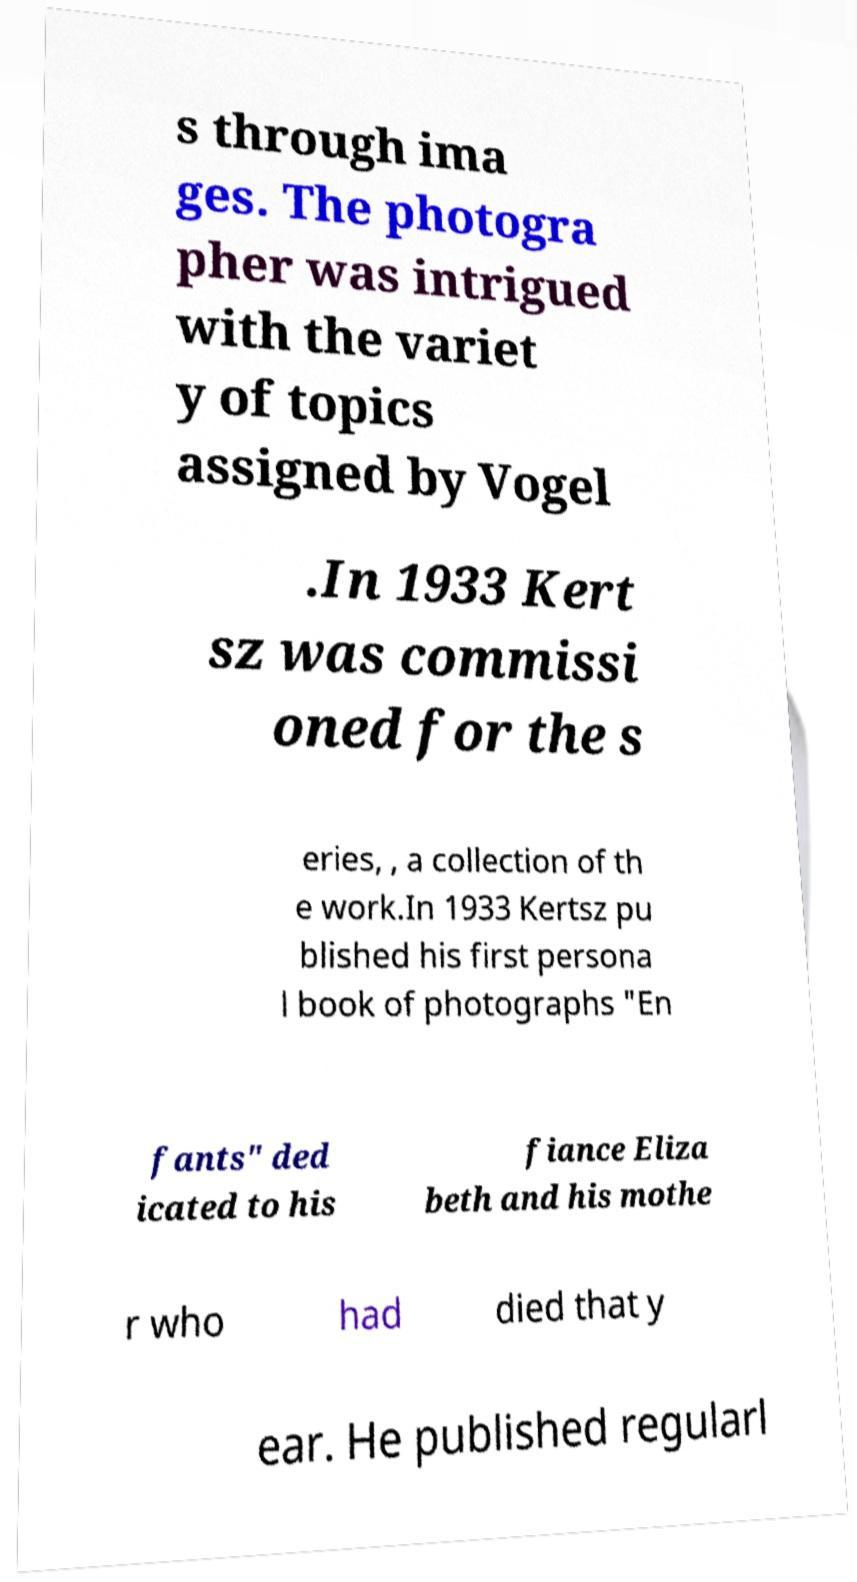What messages or text are displayed in this image? I need them in a readable, typed format. s through ima ges. The photogra pher was intrigued with the variet y of topics assigned by Vogel .In 1933 Kert sz was commissi oned for the s eries, , a collection of th e work.In 1933 Kertsz pu blished his first persona l book of photographs "En fants" ded icated to his fiance Eliza beth and his mothe r who had died that y ear. He published regularl 